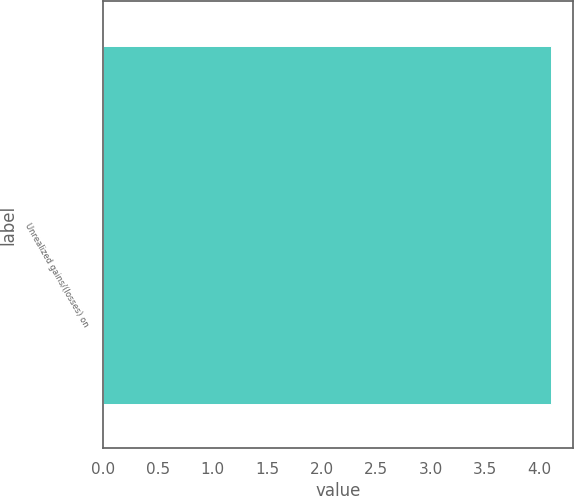Convert chart. <chart><loc_0><loc_0><loc_500><loc_500><bar_chart><fcel>Unrealized gains/(losses) on<nl><fcel>4.1<nl></chart> 